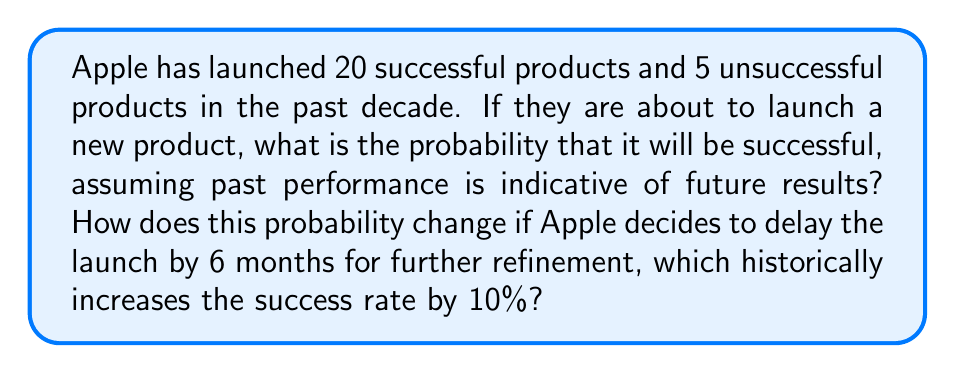Provide a solution to this math problem. Let's approach this step-by-step:

1) First, let's calculate the initial probability of success:

   Total products = 20 (successful) + 5 (unsuccessful) = 25
   
   Probability of success = $\frac{\text{Successful products}}{\text{Total products}} = \frac{20}{25} = 0.8$ or 80%

2) Now, let's consider the scenario where Apple delays the launch:

   The success rate increases by 10%, which means we multiply the current probability by 1.1:
   
   New probability = $0.8 \times 1.1 = 0.88$ or 88%

3) To calculate the increase in probability:

   Increase = New probability - Original probability
             = $0.88 - 0.80 = 0.08$ or 8%

Therefore, delaying the launch increases the probability of success by 8 percentage points.
Answer: 80%; increases to 88% if delayed 